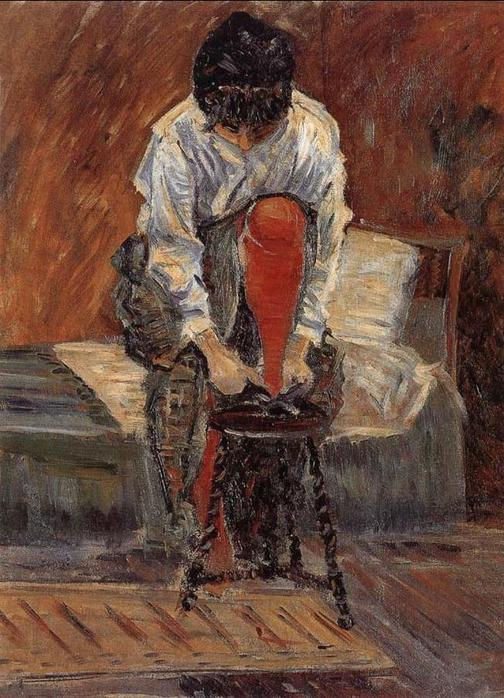How does the painter’s technique influence the viewer’s perception of the scene? The painter's brushwork, with its visible strokes and textures, adds a tactile quality to the scene, making it feel alive and dynamic despite its stillness. This technique draws the viewer into the space of the woman, fostering a tactile connection that enhances the feeling of intimacy and personal reflection depicted in the artwork. 